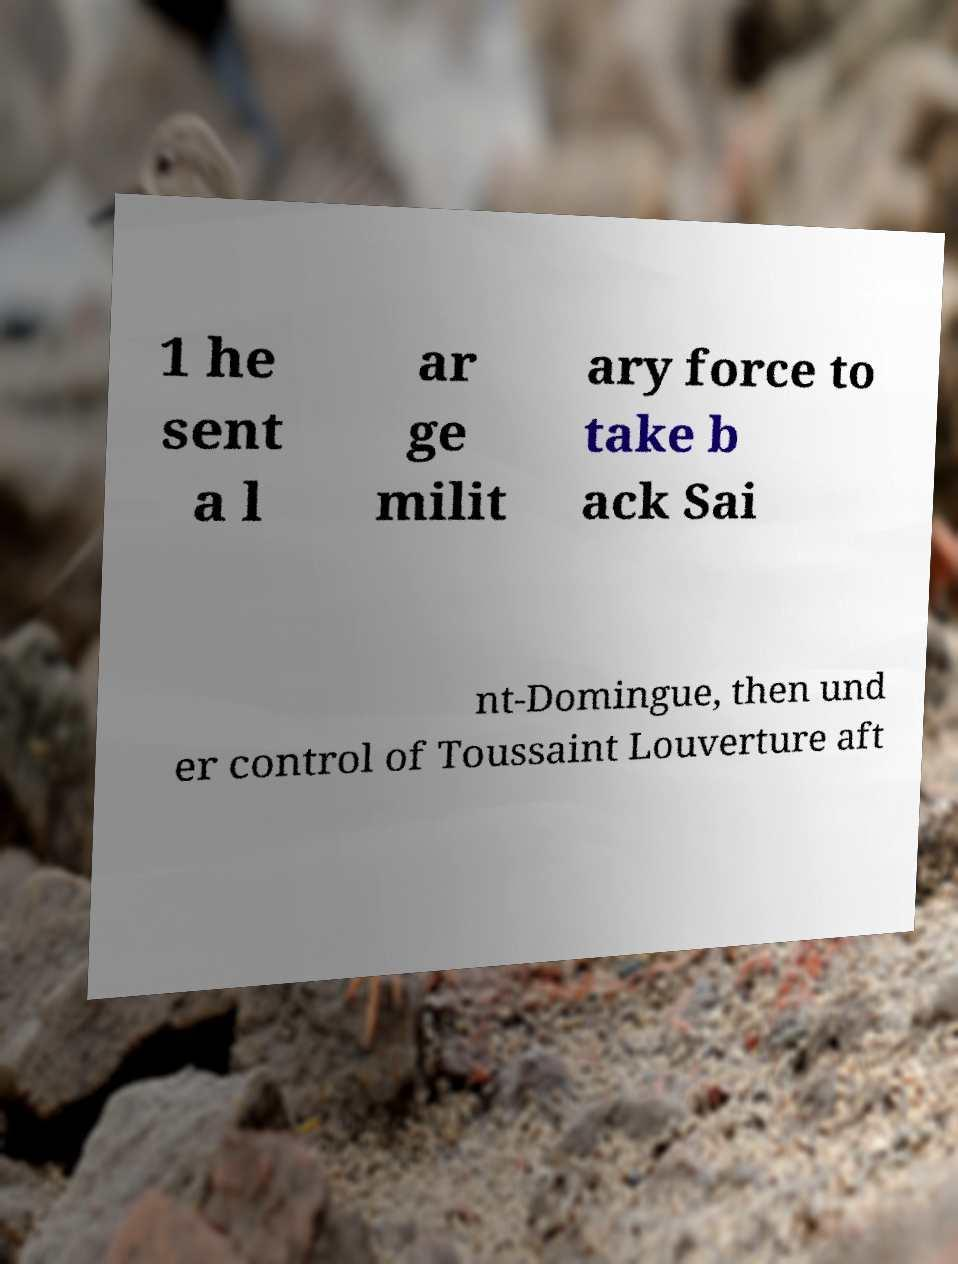Could you extract and type out the text from this image? 1 he sent a l ar ge milit ary force to take b ack Sai nt-Domingue, then und er control of Toussaint Louverture aft 